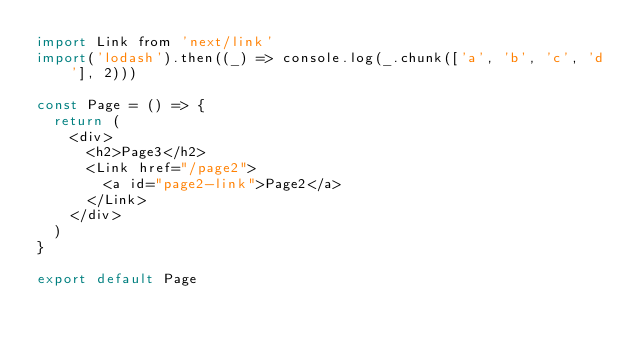<code> <loc_0><loc_0><loc_500><loc_500><_JavaScript_>import Link from 'next/link'
import('lodash').then((_) => console.log(_.chunk(['a', 'b', 'c', 'd'], 2)))

const Page = () => {
  return (
    <div>
      <h2>Page3</h2>
      <Link href="/page2">
        <a id="page2-link">Page2</a>
      </Link>
    </div>
  )
}

export default Page
</code> 